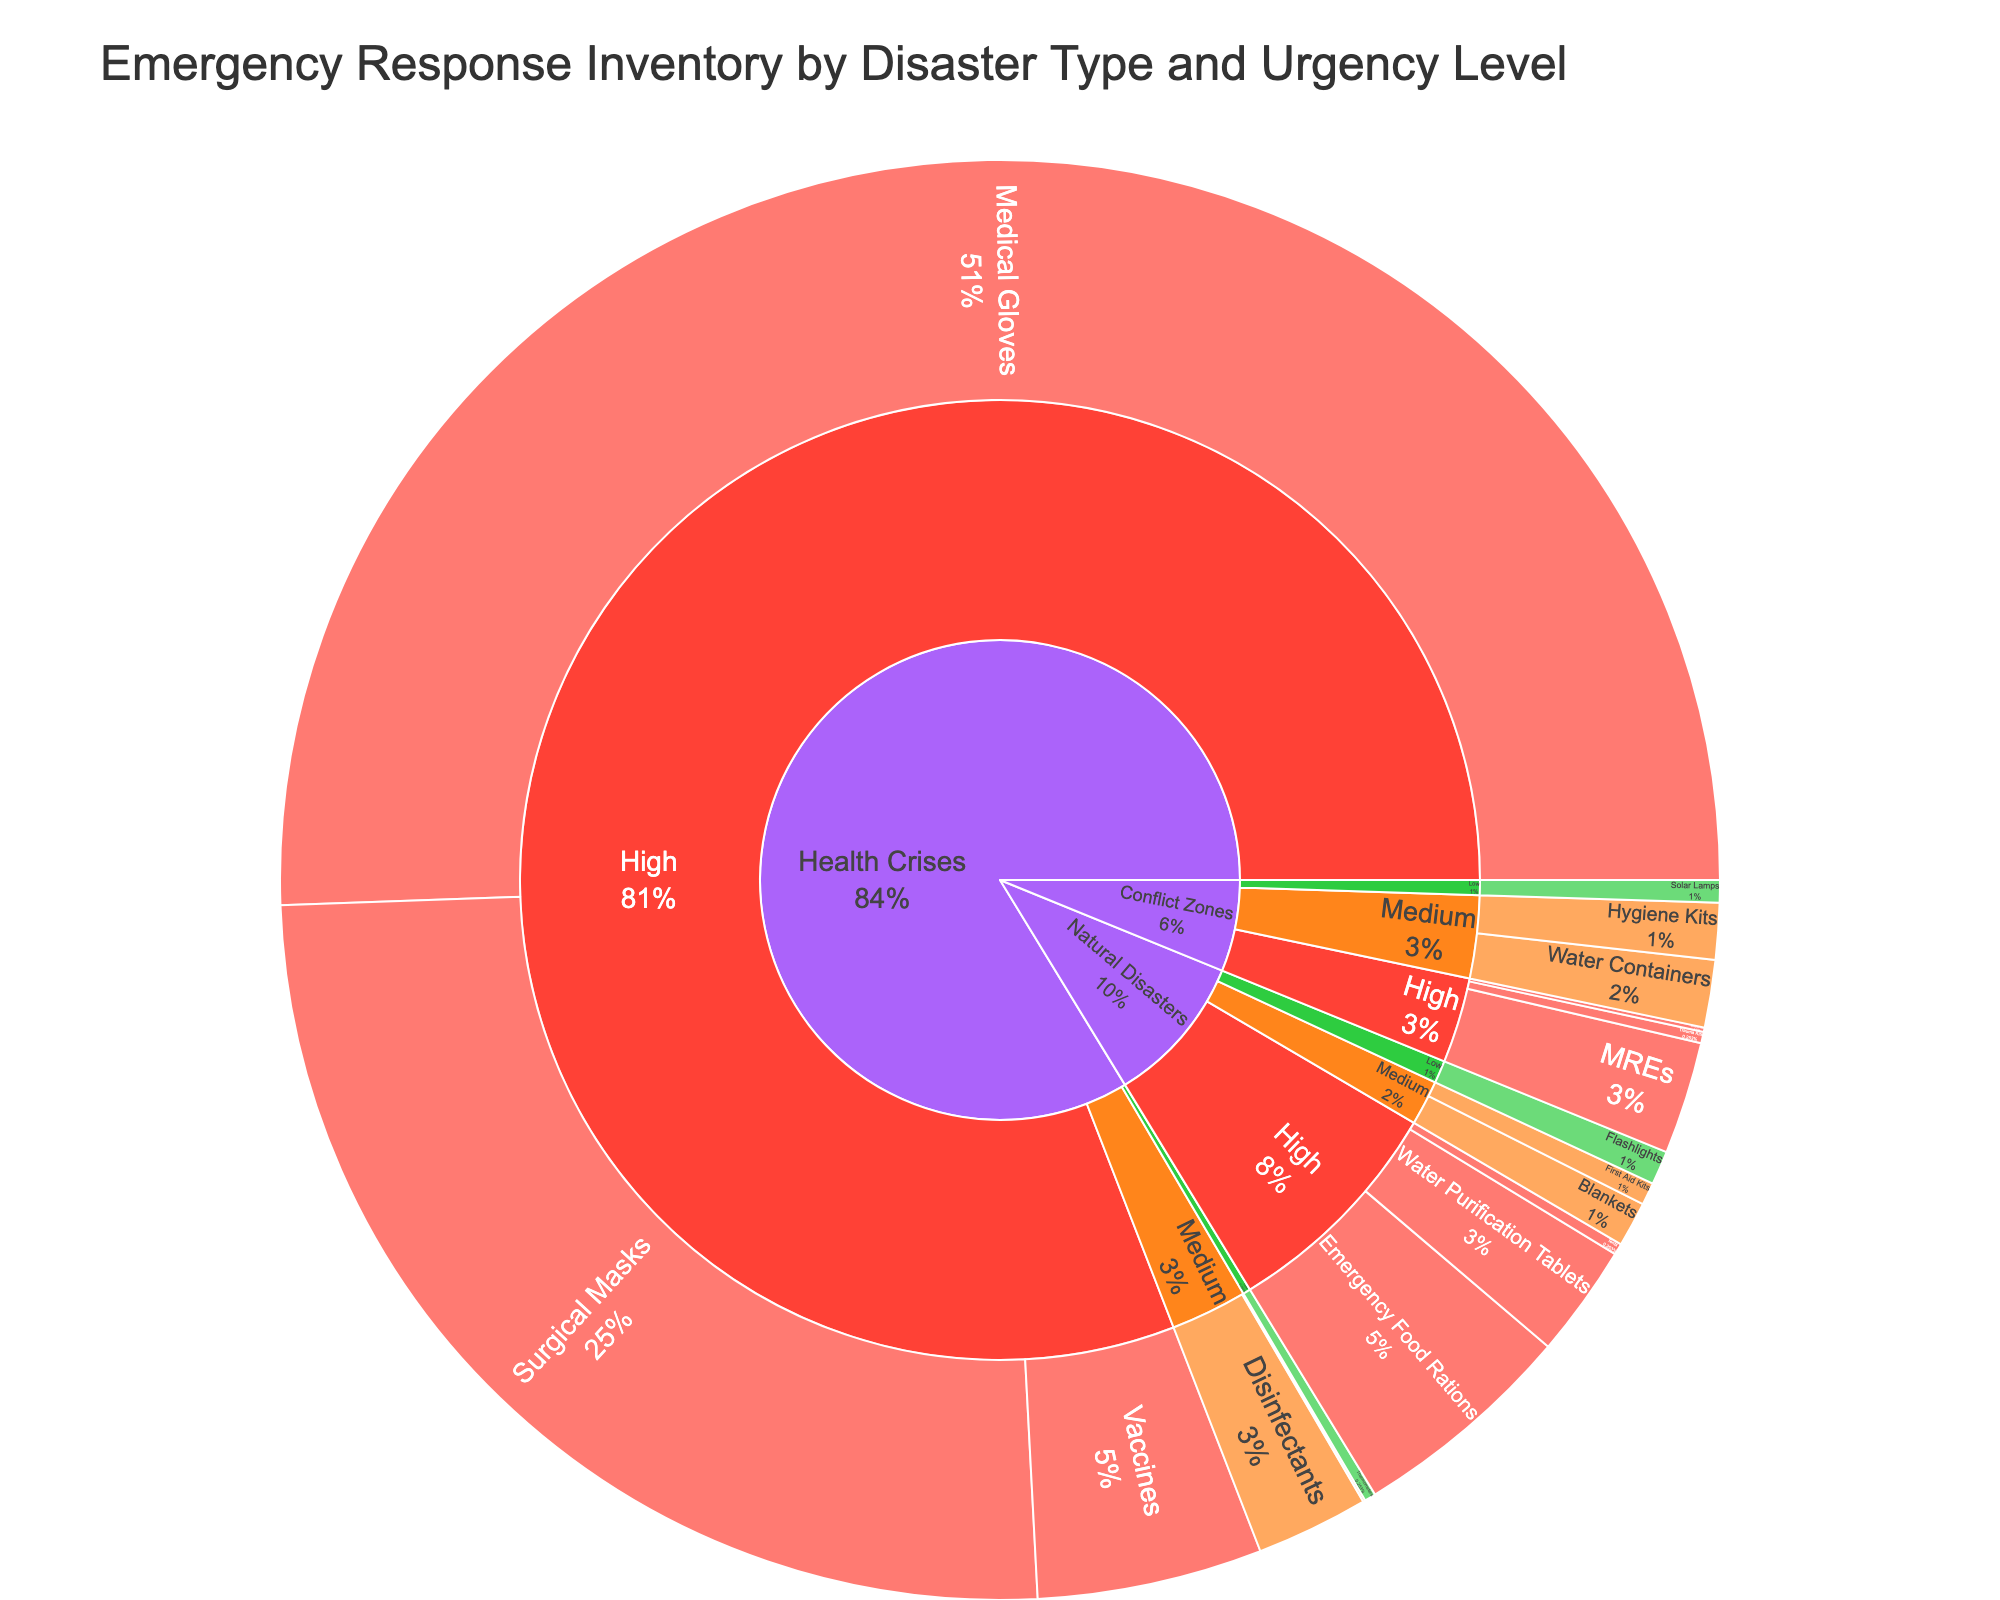What is the title of the figure? The title is usually located at the top of the figure and provides a summary of what the visualization is about. In this case, it is labeled as "Emergency Response Inventory by Disaster Type and Urgency Level."
Answer: Emergency Response Inventory by Disaster Type and Urgency Level Which urgency level has the highest quantity of items for natural disasters? By looking at the section for 'Natural Disasters' and noting each urgency level, we can see that 'High' urgency holds items like Water Purification Tablets, Tents, and Emergency Food Rations which have substantial quantities.
Answer: High How many items are listed under 'Health Crises' with 'Medium' urgency level? We look at the `Health Crises` section, then focus on the `Medium` urgency level. The items listed under this section are 'Disinfectants' and 'Hospital Beds', which are two items.
Answer: 2 Which item has the highest quantity across all categories? The sunburst plot highlights the quantity of items. By observing the entire plot, we find that 'Medical Gloves' under 'Health Crises' with 'High' urgency has the highest quantity at 1,000,000.
Answer: Medical Gloves Compare the quantity of 'Bulletproof Vests' to 'Tents'. Which one is greater and by how much? 'Bulletproof Vests' has a quantity of 2,000 and 'Tents' has a quantity of 5,000. The difference in quantity is 5,000 - 2,000.
Answer: Tents, 3,000 What is the combined quantity of items with 'Medium' urgency under 'Conflict Zones'? To find this, sum the quantities of 'Water Containers' (30,000) and 'Hygiene Kits' (25,000) under 'Conflict Zones' with 'Medium' urgency. 30,000 + 25,000.
Answer: 55,000 How does the quantity of 'Solar Lamps' in conflict zones (low urgency) compare to 'Thermometers' in health crises (low urgency)? 'Solar Lamps' has a quantity of 10,000 and 'Thermometers' has a quantity of 5,000. Solar Lamps have more quantity.
Answer: Solar Lamps, 5,000 more What percentage of 'High' urgency items are in the 'Health Crises' category? We add the quantities of all 'High' urgency items in 'Health Crises' (Surgical Masks 500,000, Vaccines 100,000, Medical Gloves 1,000,000) = 1,600,000. Calculate the total quantity of all 'High' urgency items across all categories, then divide 'Health Crises' quantity by this total and multiply by 100.
Answer: 1,600,000/1,887,000 * 100 ≈ 84.8% How many total quantities of items are there under the 'Low' urgency level? Sum the quantities of all items under 'Low' urgency level. This includes 'Flashlights' (15,000), 'Solar Lamps' (10,000), and 'Thermometers' (5,000). 15,000 + 10,000 + 5,000.
Answer: 30,000 Which disaster type has the most items categorized under it and how many items does it include? By examining the outermost ring of the Sunburst plot for the different disaster types and counting the items under each, health crises have the most items. The grand total of items can be seen in the breakdowns of high, medium, and low urgency levels to get the comprehensive count.
Answer: Health Crises, 6 items 